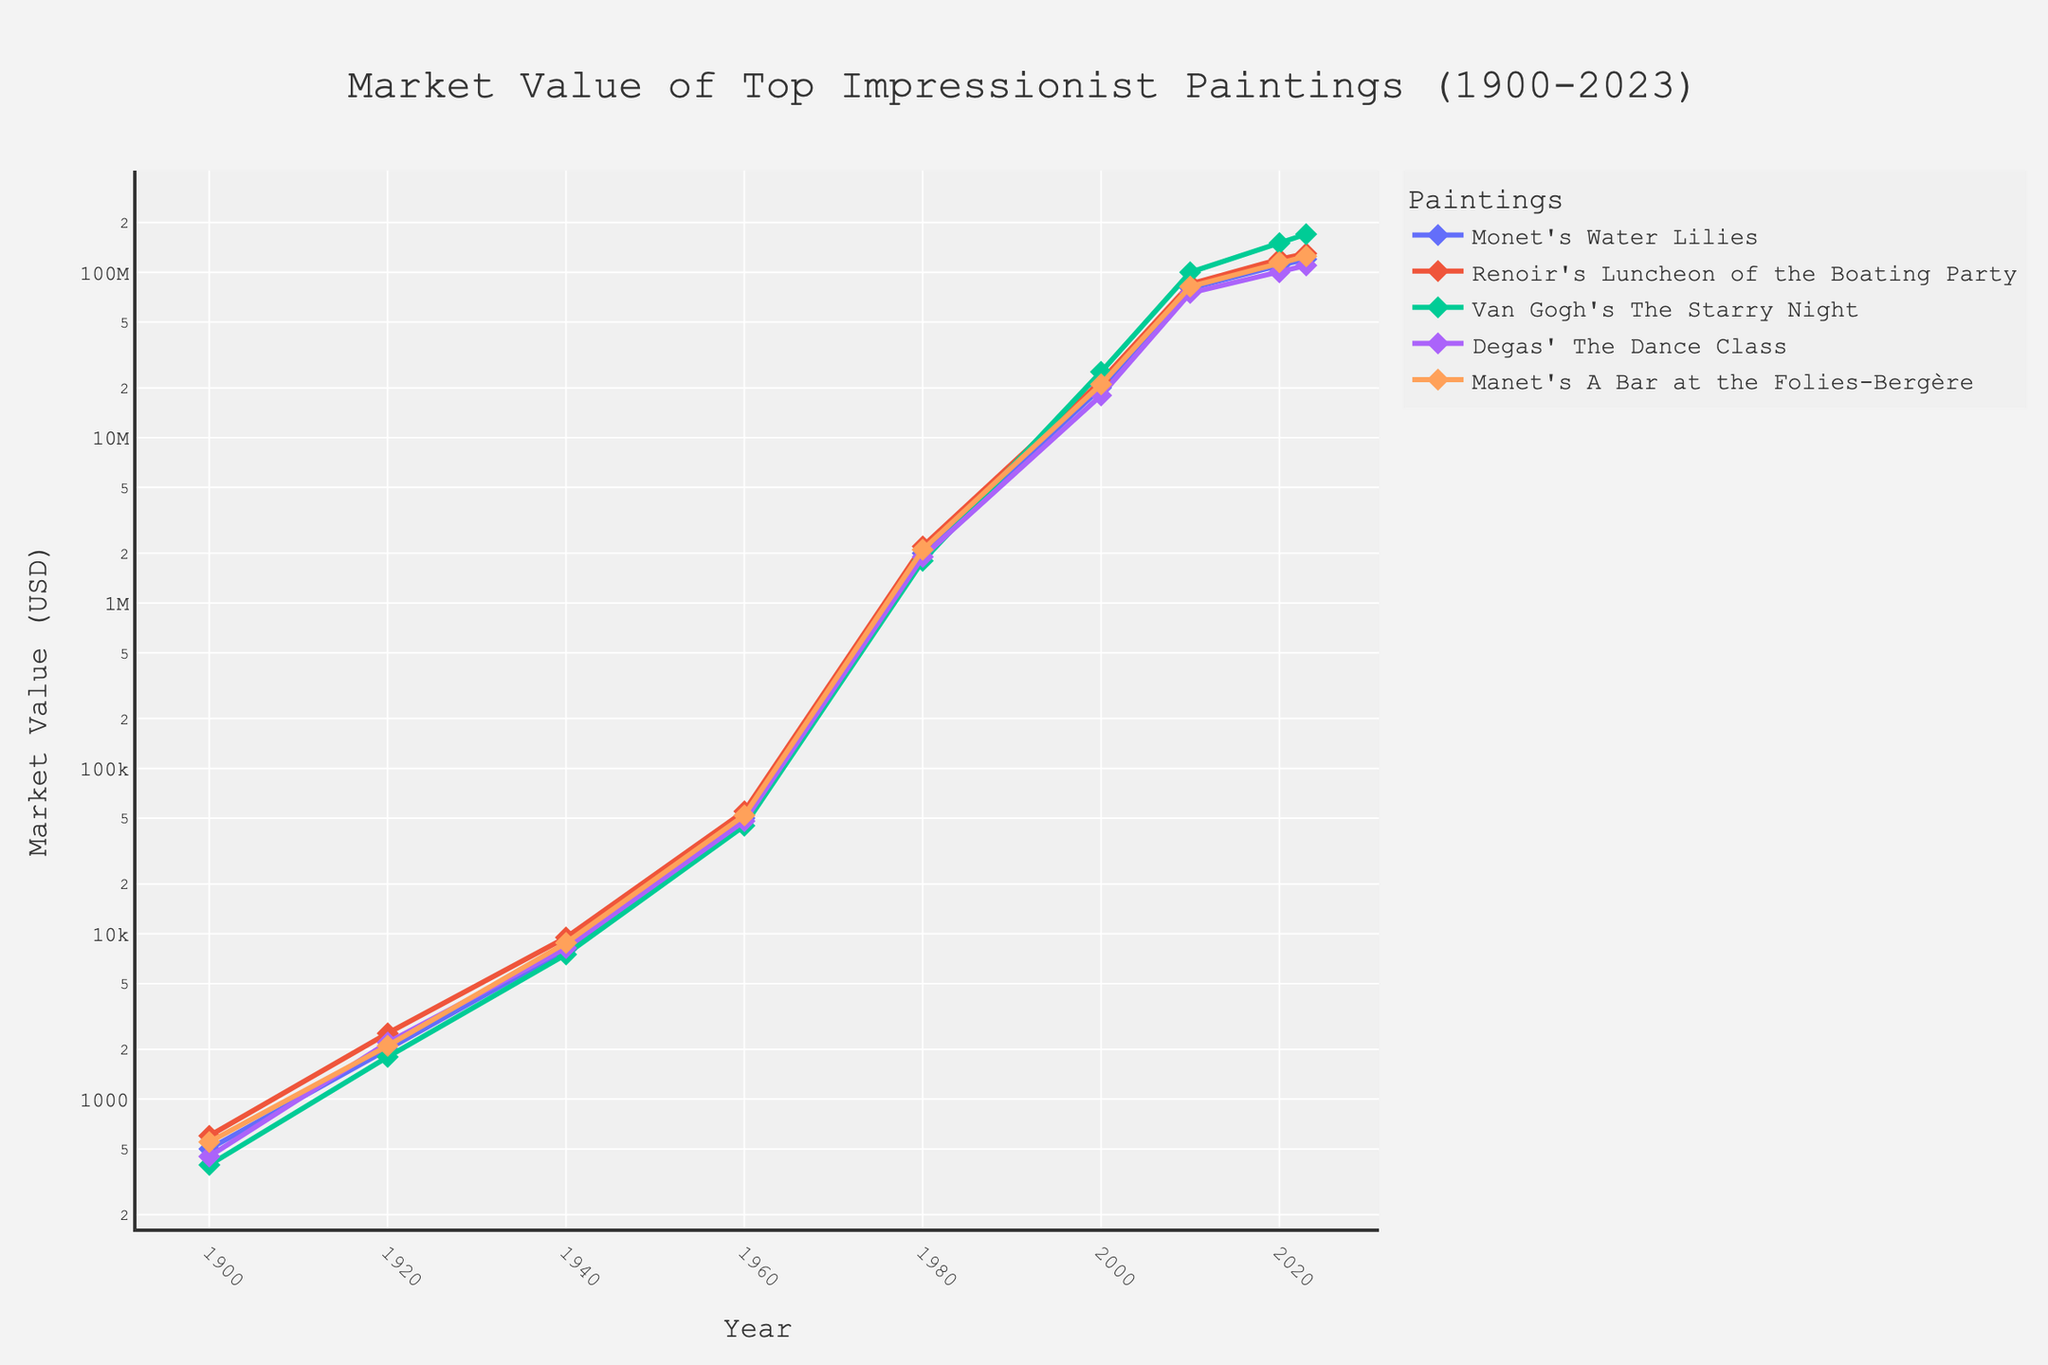What's the highest market value for Van Gogh's The Starry Night? Look at the line representing Van Gogh's The Starry Night and identify the highest point. From the figure, the highest point is at the year 2023.
Answer: 170,000,000 USD Which painting had the highest market value in 1960? Examine the markers for each painting at the year 1960. Compare the values of Monet's Water Lilies, Renoir's Luncheon of the Boating Party, Van Gogh's The Starry Night, Degas' The Dance Class, and Manet's A Bar at the Folies-Bergère.
Answer: Renoir's Luncheon of the Boating Party Between 1920 and 1940, which painting's value grew the most? Calculate the difference in market value from 1920 to 1940 for each painting. Monet's Water Lilies grew from 2000 to 8000, Renoir's Luncheon of the Boating Party from 2500 to 9500, Van Gogh's The Starry Night from 1800 to 7500, Degas' The Dance Class from 2200 to 8200, and Manet's A Bar at the Folies-Bergère from 2100 to 8800. The largest difference is the growth from 1920 to 1940 for Renoir's Luncheon of the Boating Party, which increased by 7000.
Answer: Renoir's Luncheon of the Boating Party What was the market value difference between Manet's A Bar at the Folies-Bergère and Degas' The Dance Class in the year 2020? Check the values for Manet's A Bar at the Folies-Bergère and Degas' The Dance Class in 2020. Manet’s painting is at 115,000,000 while Degas’ painting is at 100,000,000. Subtract the latter from the former.
Answer: 15,000,000 USD How did the market value of Monet’s Water Lilies change from 1900 to 2000? Look at the market values in 1900 and 2000. Monet's Water Lilies increased from 500 to 20,000,000. Calculate the difference.
Answer: 19,999,500 USD Which painting experienced the largest percentage increase from 2000 to 2010? Calculate the percentage increase from 2000 to 2010 for each painting. Monet's Water Lilies: ((80,000,000 - 20,000,000) / 20,000,000) * 100 = 300%, Renoir's Luncheon of the Boating Party: ((85,000,000 - 22,000,000) / 22,000,000) * 100 = 286.36%, Van Gogh's The Starry Night: ((100,000,000 - 25,000,000) / 25,000,000) * 100 = 300%, Degas' The Dance Class: ((75,000,000 - 18,000,000) / 18,000,000) * 100 = 316.67%, Manet's A Bar at The Folies-Bergère: ((82,000,000 - 21,000,000) / 21,000,000) * 100 = 290.48%.
Answer: Degas' The Dance Class Which painting had the lowest market value in 1900 and what was it? Examine the market values of all paintings in 1900: Monet's Water Lilies (500), Renoir's Luncheon of the Boating Party (600), Van Gogh's The Starry Night (400), Degas' The Dance Class (450), and Manet's A Bar at the Folies-Bergère (550).
Answer: Van Gogh's The Starry Night, 400 USD What's the median market value of Monet's Water Lilies over the years provided? Arrange the values for Monet's Water Lilies in ascending order: 500, 2000, 8000, 50000, 2,000,000, 20,000,000, 80,000,000, 110,000,000, 120,000,000. Since there are 9 numbers, the median is the 5th number.
Answer: 2,000,000 USD 